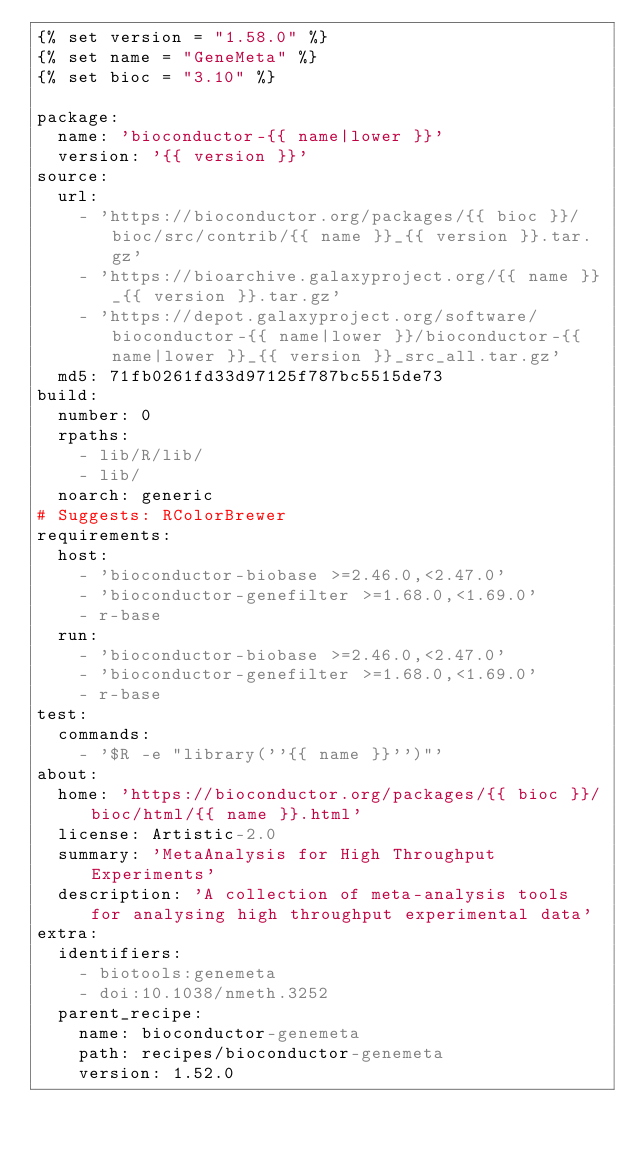<code> <loc_0><loc_0><loc_500><loc_500><_YAML_>{% set version = "1.58.0" %}
{% set name = "GeneMeta" %}
{% set bioc = "3.10" %}

package:
  name: 'bioconductor-{{ name|lower }}'
  version: '{{ version }}'
source:
  url:
    - 'https://bioconductor.org/packages/{{ bioc }}/bioc/src/contrib/{{ name }}_{{ version }}.tar.gz'
    - 'https://bioarchive.galaxyproject.org/{{ name }}_{{ version }}.tar.gz'
    - 'https://depot.galaxyproject.org/software/bioconductor-{{ name|lower }}/bioconductor-{{ name|lower }}_{{ version }}_src_all.tar.gz'
  md5: 71fb0261fd33d97125f787bc5515de73
build:
  number: 0
  rpaths:
    - lib/R/lib/
    - lib/
  noarch: generic
# Suggests: RColorBrewer
requirements:
  host:
    - 'bioconductor-biobase >=2.46.0,<2.47.0'
    - 'bioconductor-genefilter >=1.68.0,<1.69.0'
    - r-base
  run:
    - 'bioconductor-biobase >=2.46.0,<2.47.0'
    - 'bioconductor-genefilter >=1.68.0,<1.69.0'
    - r-base
test:
  commands:
    - '$R -e "library(''{{ name }}'')"'
about:
  home: 'https://bioconductor.org/packages/{{ bioc }}/bioc/html/{{ name }}.html'
  license: Artistic-2.0
  summary: 'MetaAnalysis for High Throughput Experiments'
  description: 'A collection of meta-analysis tools for analysing high throughput experimental data'
extra:
  identifiers:
    - biotools:genemeta
    - doi:10.1038/nmeth.3252
  parent_recipe:
    name: bioconductor-genemeta
    path: recipes/bioconductor-genemeta
    version: 1.52.0

</code> 